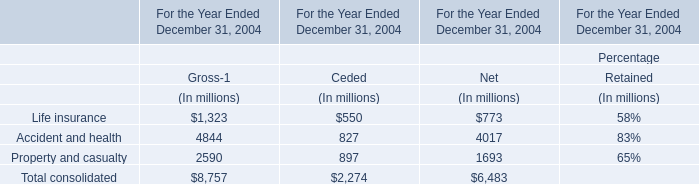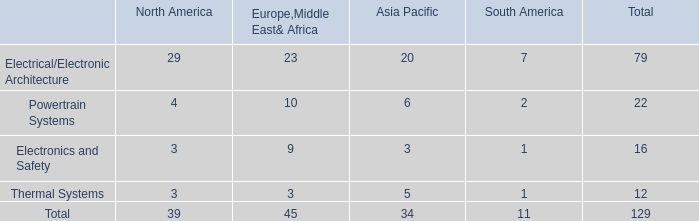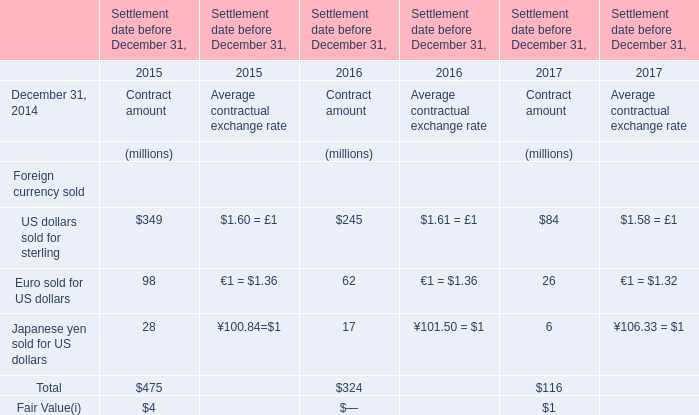How many Contract amount exceed the average of Contract amount in 2015? 
Answer: 1. 